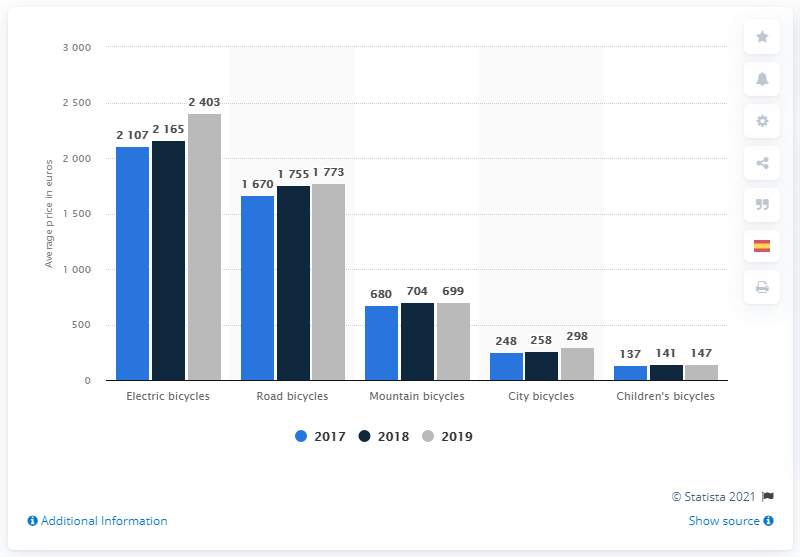Point out several critical features in this image. The highest average price of road bicycles sold in Spain in 2019, by type, was 1,773 euros. The difference between the shortest light blue bar and the tallest dark blue bar is -2028. Electric bicycles were the most expensive type of bicycle that Spanish cyclists could purchase. 